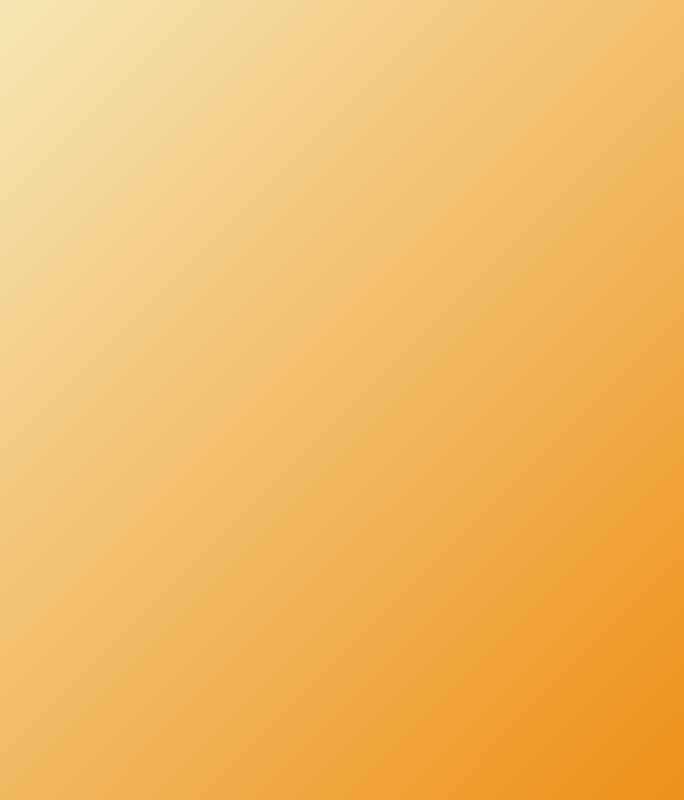What is the title of the book? The title of the book is prominently displayed at the top of the cover design.
Answer: Gala Night Extravaganza What is the subtitle of the book? The subtitle provides additional context about the content of the book.
Answer: A Journey Through Our Star-Studded Charity Events What colors dominate the book cover design? The design features a combination of golden hues and white elements.
Answer: Golden hues Who is the author of the book? The author's name is mentioned at the bottom of the overlay.
Answer: A Philanthropic Socialite What type of events are showcased in the book? The cover suggests that the book highlights specific types of events based on the title and subtitle.
Answer: Charity events How many images are present in the image grid? The structure of the image grid indicates the total number of displayed images.
Answer: Four images What phrase highlights the main focus of the book? The highlight phrase is designed to draw attention to the impact of the events discussed in the book.
Answer: Showcasing the impact and glamour of each gala What is the background gradient color of the cover? The background features a smooth transition between two specific colors in the gradient.
Answer: Light yellow to orange What type of visual elements are used in the design? The design consists of overlays, text, and image grids that contribute to its overall appearance.
Answer: Images and text 